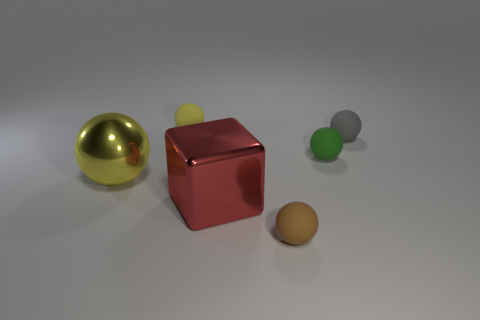What number of balls are matte things or brown objects?
Ensure brevity in your answer.  4. What number of objects have the same color as the large metallic block?
Provide a short and direct response. 0. What is the size of the rubber ball that is behind the green thing and right of the shiny block?
Offer a very short reply. Small. Are there fewer small green matte objects on the left side of the large sphere than large yellow matte cylinders?
Your response must be concise. No. Does the green ball have the same material as the large red block?
Offer a terse response. No. What number of things are either large metal balls or gray matte objects?
Your answer should be very brief. 2. How many green things have the same material as the tiny gray sphere?
Your answer should be compact. 1. What is the size of the other shiny object that is the same shape as the gray object?
Provide a succinct answer. Large. There is a tiny gray matte ball; are there any tiny rubber things behind it?
Your answer should be compact. Yes. What material is the brown sphere?
Make the answer very short. Rubber. 